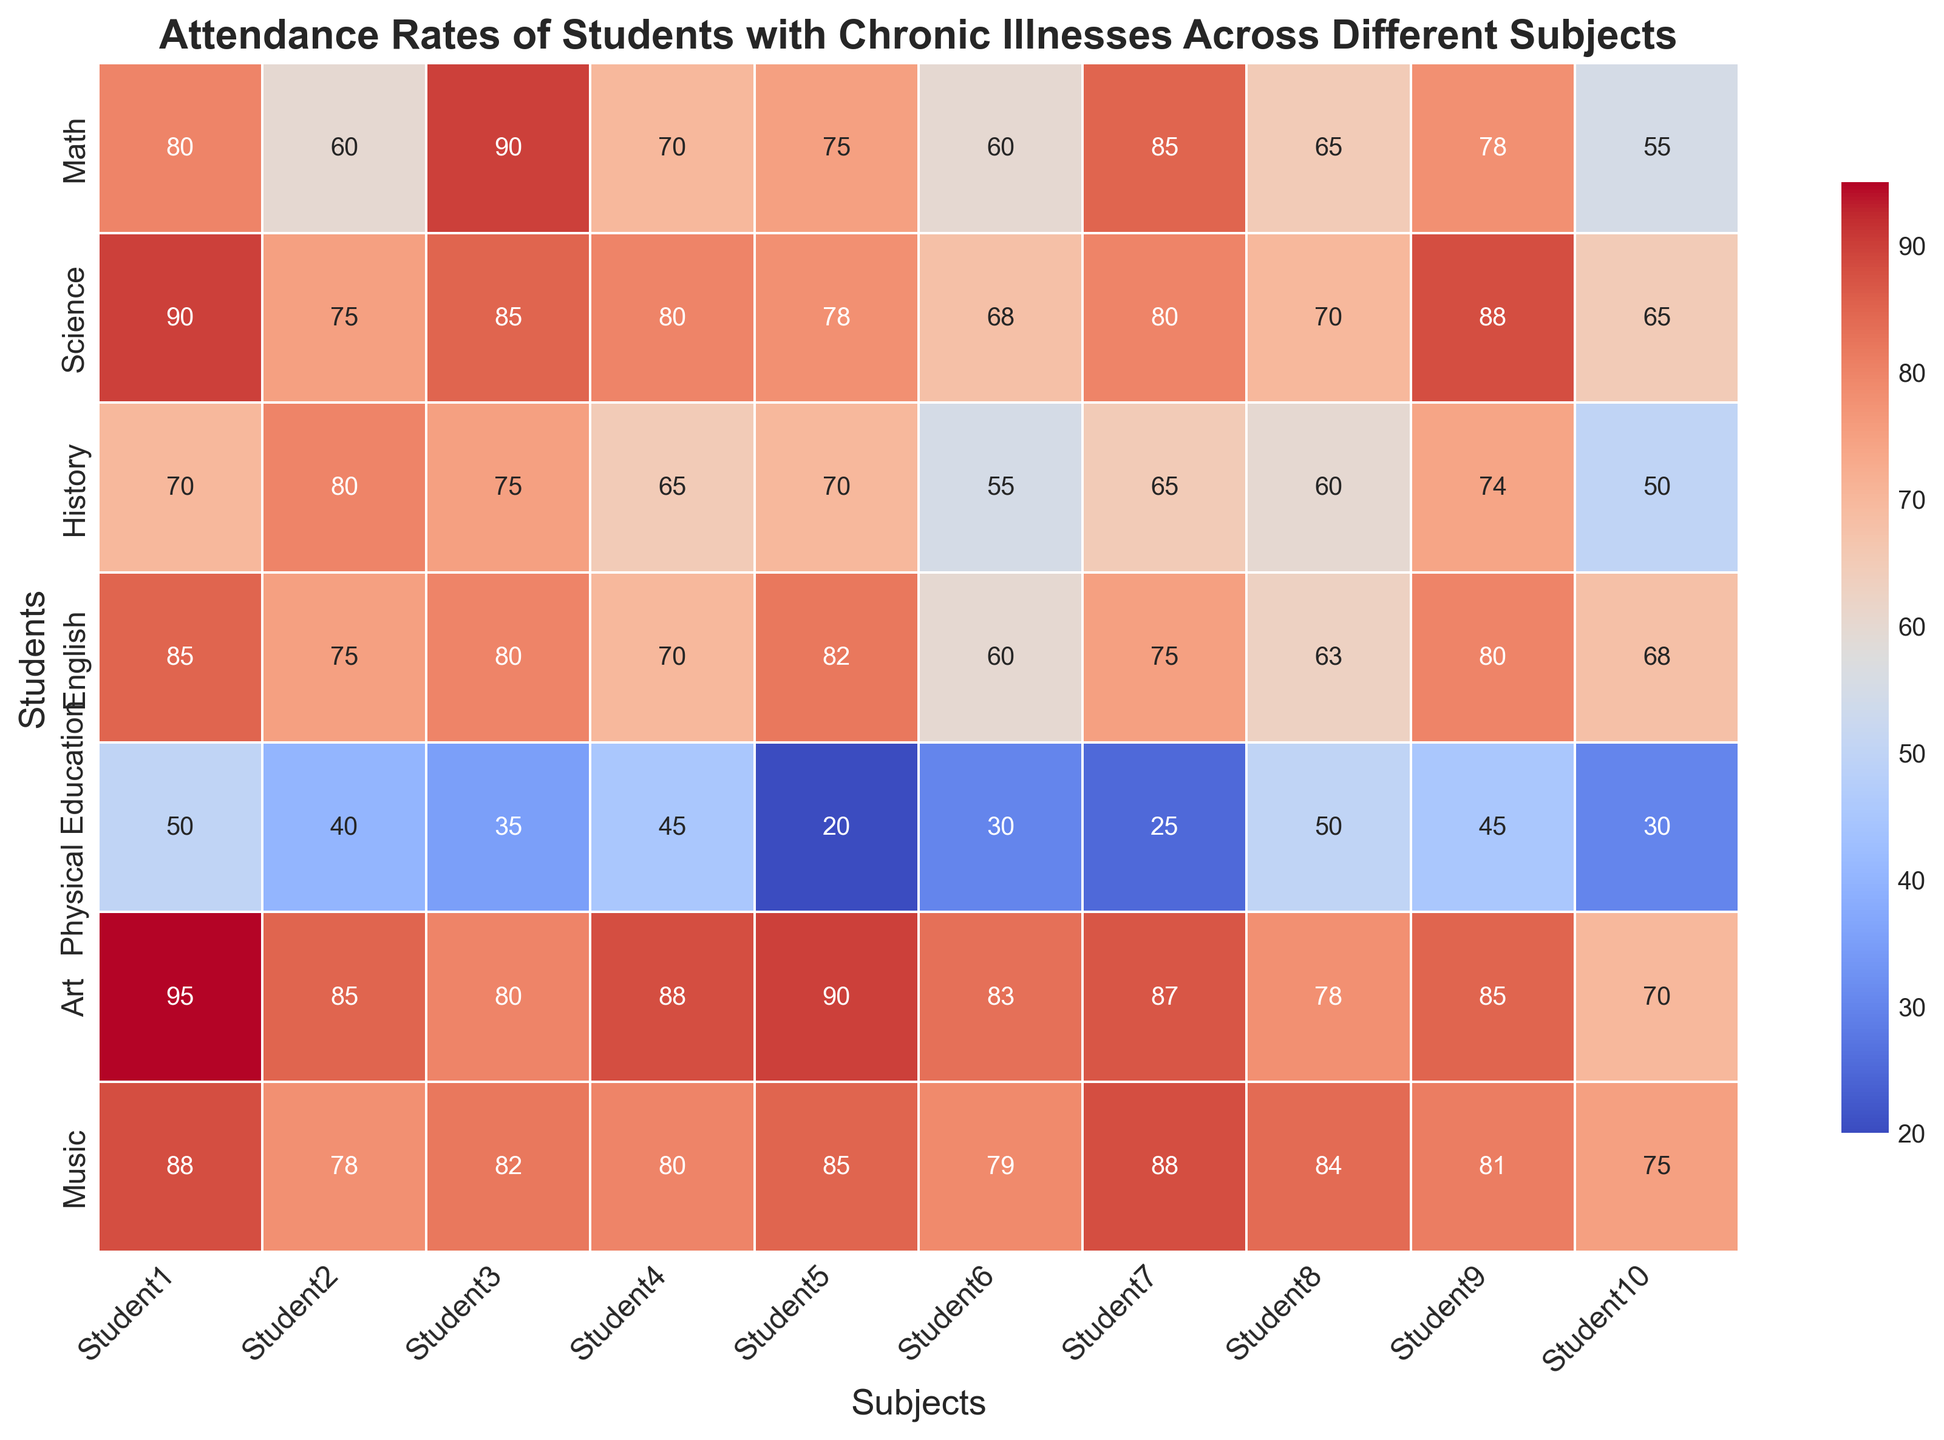What is the average attendance rate for Math across all students? First, locate the attendance rates for Math for all the students on the heatmap. Then, sum these rates and divide by the total number of students. For Math, the values are 80, 60, 90, 70, 75, 60, 85, 65, 78, 55. Adding these gives 718, and dividing by 10 (total number of students) gives 71.8
Answer: 71.8 Which subject has the highest attendance rate for Student3? Look at the row corresponding to Student3. Find the highest value across all subjects. For Student3, the values are 90, 85, 75, 80, 35, 80, 82. The highest value is 90 in Math
Answer: Math Which student has the lowest attendance rate in Physical Education? Locate the column for Physical Education and identify the lowest value across all students. For Physical Education, the values are 50, 40, 35, 45, 20, 30, 25, 50, 45, 30. The lowest value is 20 which belongs to Student5
Answer: Student5 Compare the attendance rates for Student1 and Student2 in English. Who has a higher rate? Locate the attendance rates for English for both Student1 and Student2. For Student1, it is 85 and for Student2 it is 75. Therefore, Student1 has a higher attendance rate than Student2 in English
Answer: Student1 What is the range of attendance rates in Art for Student4 and Student5? Locate the attendance rates for Art for both Student4 and Student5. For Student4, it is 88 and for Student5, it is 90. The range is the difference between the highest and lowest values, which is 90 - 88 = 2
Answer: 2 Which subject shows the most consistent attendance rates across all students? To find the subject with the most consistent attendance rates, we should look for the column where values have the least variability. From a quick look, Art seems to be quite consistent with high values and smaller differences compared to the others
Answer: Art What is the difference in attendance rates between Student6 and Student10 in Science? Locate the attendance rates for Science for both Student6 and Student10. For Student6, it is 68 and for Student10 it is 65. The difference is 68 - 65 = 3
Answer: 3 What are the median attendance rates for all subjects for Student7? First, list in ascending order the attendance rates across all subjects for Student7: 25, 65, 75, 80, 85, 87, 88. The median value (middle value in a sorted list) is 80, since there are 7 values
Answer: 80 Describe the general trend in attendance rates in Physical Education compared to other subjects. Visually, the attendance rates for Physical Education are lower compared to most other subjects, indicating a trend of lower attendance rates in this subject overall
Answer: Lower 